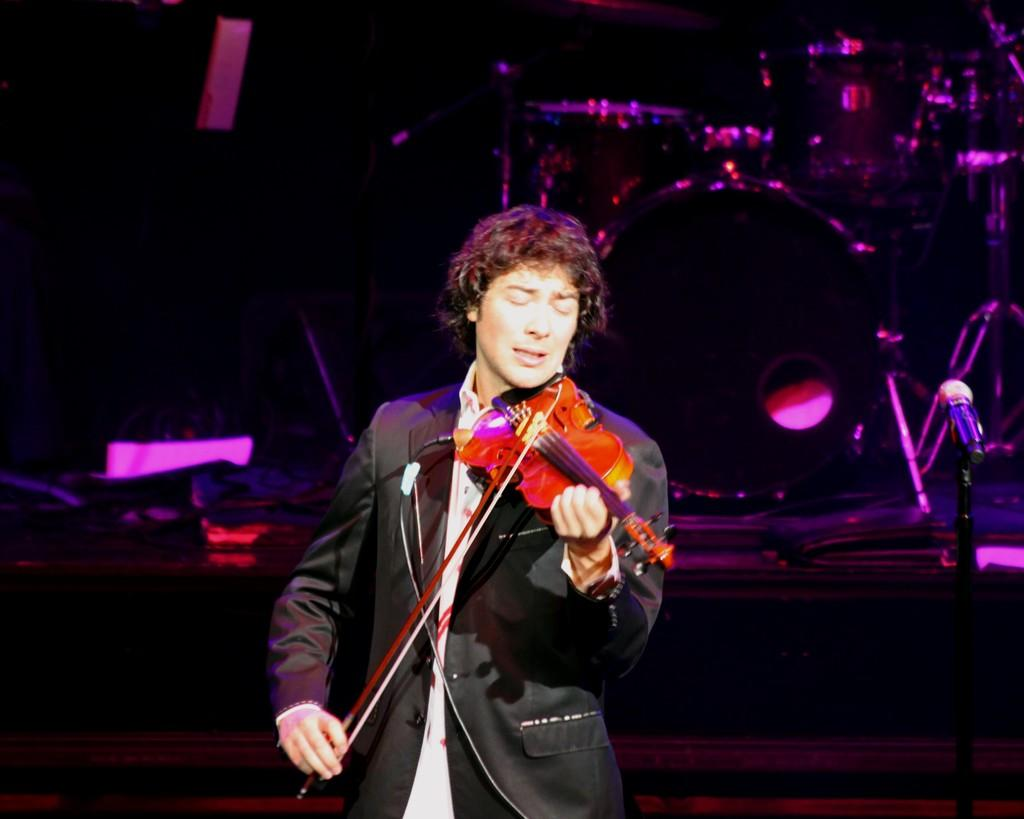Who is the main subject of the subject in the image? There is a man in the image. Where is the man positioned in the image? The man is standing in the middle of the image. What is the man holding in the image? The man is holding a music instrument in yellow color. What is the man doing with the microphone? The man is singing into a microphone. What type of monkey can be seen playing the yellow music instrument in the image? There is no monkey present in the image, and the man is the one holding the yellow music instrument. What is the manager's role in the image? There is no mention of a manager in the image, as the focus is on the man holding the music instrument and singing into a microphone. 